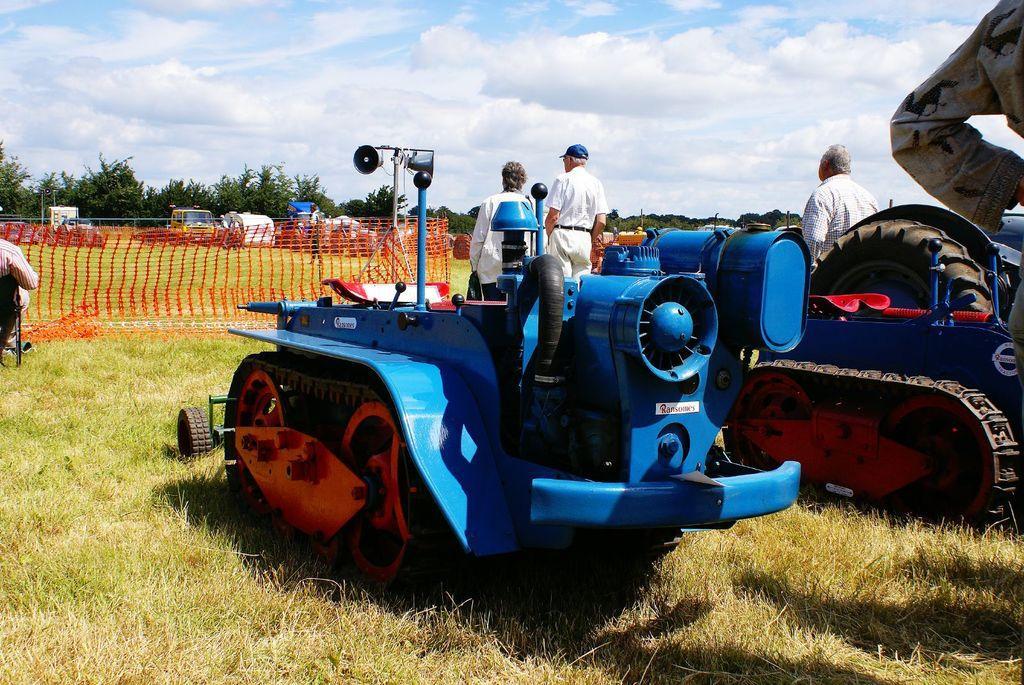Can you describe this image briefly? In this image we can see there are persons. And there are vehicles, chair, speaker, net and trees. And at the top there is a sky. 